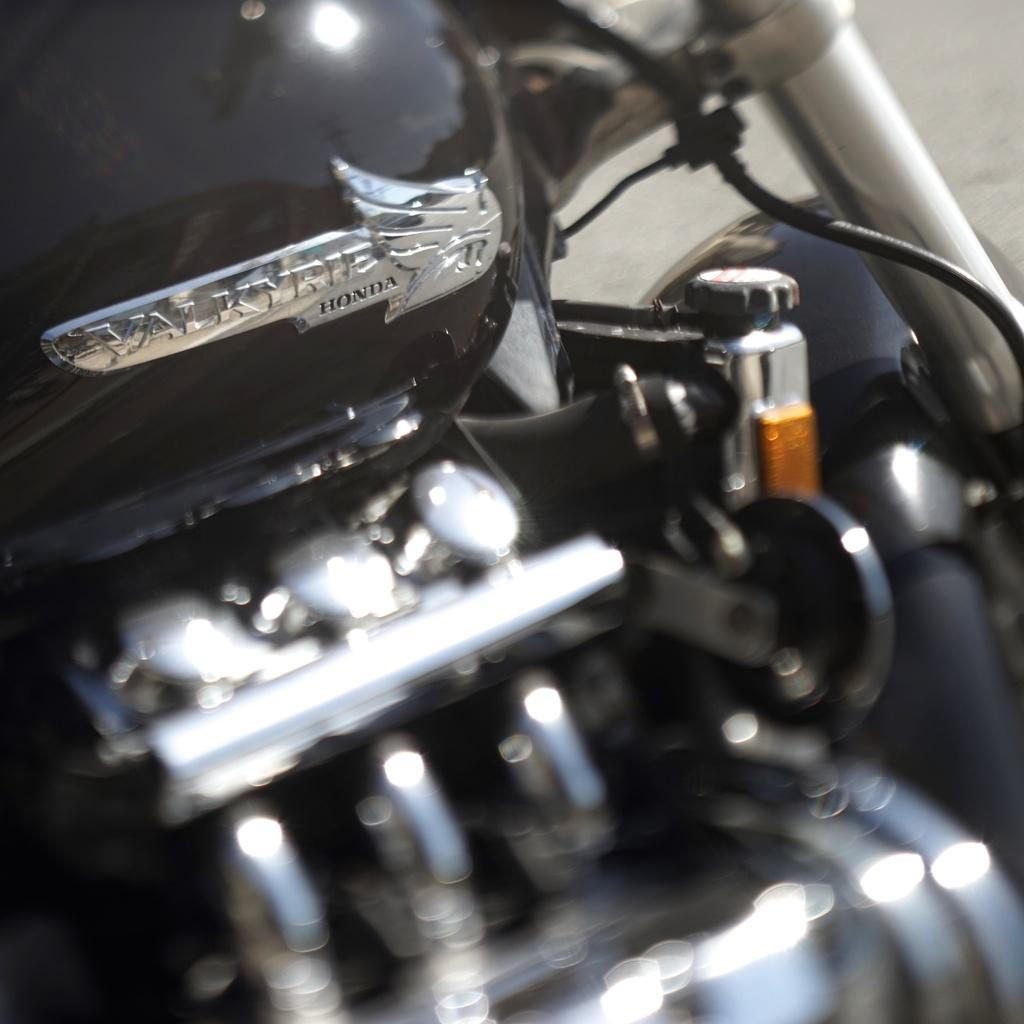What type of vehicle is in the image? There is a motorcycle in the image. What colors can be seen on the motorcycle? The motorcycle is black and silver in color. How much of the motorcycle is visible in the image? The image appears to be a cropped or truncated view of the motorcycle. Can you read any text on the motorcycle? Yes, there is text written on the motorcycle, visible on the top left side. What is the relation between the motorcycle and the governor in the image? There is no governor present in the image, and no indication of a relation between the motorcycle and a governor. 